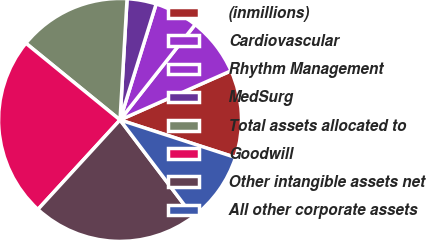Convert chart. <chart><loc_0><loc_0><loc_500><loc_500><pie_chart><fcel>(inmillions)<fcel>Cardiovascular<fcel>Rhythm Management<fcel>MedSurg<fcel>Total assets allocated to<fcel>Goodwill<fcel>Other intangible assets net<fcel>All other corporate assets<nl><fcel>11.63%<fcel>7.75%<fcel>5.81%<fcel>3.88%<fcel>15.04%<fcel>24.06%<fcel>22.12%<fcel>9.69%<nl></chart> 